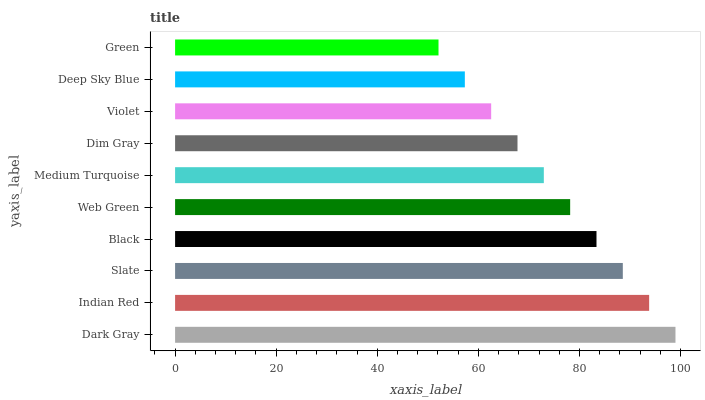Is Green the minimum?
Answer yes or no. Yes. Is Dark Gray the maximum?
Answer yes or no. Yes. Is Indian Red the minimum?
Answer yes or no. No. Is Indian Red the maximum?
Answer yes or no. No. Is Dark Gray greater than Indian Red?
Answer yes or no. Yes. Is Indian Red less than Dark Gray?
Answer yes or no. Yes. Is Indian Red greater than Dark Gray?
Answer yes or no. No. Is Dark Gray less than Indian Red?
Answer yes or no. No. Is Web Green the high median?
Answer yes or no. Yes. Is Medium Turquoise the low median?
Answer yes or no. Yes. Is Black the high median?
Answer yes or no. No. Is Dim Gray the low median?
Answer yes or no. No. 